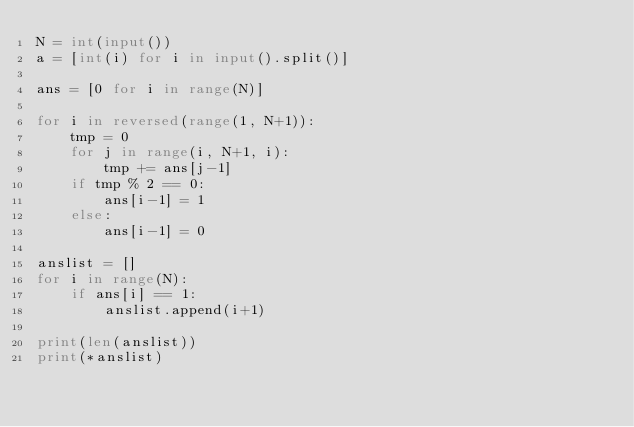Convert code to text. <code><loc_0><loc_0><loc_500><loc_500><_Python_>N = int(input())
a = [int(i) for i in input().split()]

ans = [0 for i in range(N)]

for i in reversed(range(1, N+1)):
    tmp = 0
    for j in range(i, N+1, i):
        tmp += ans[j-1]
    if tmp % 2 == 0:
        ans[i-1] = 1
    else:
        ans[i-1] = 0

anslist = []
for i in range(N):
    if ans[i] == 1:
        anslist.append(i+1)

print(len(anslist))
print(*anslist)</code> 